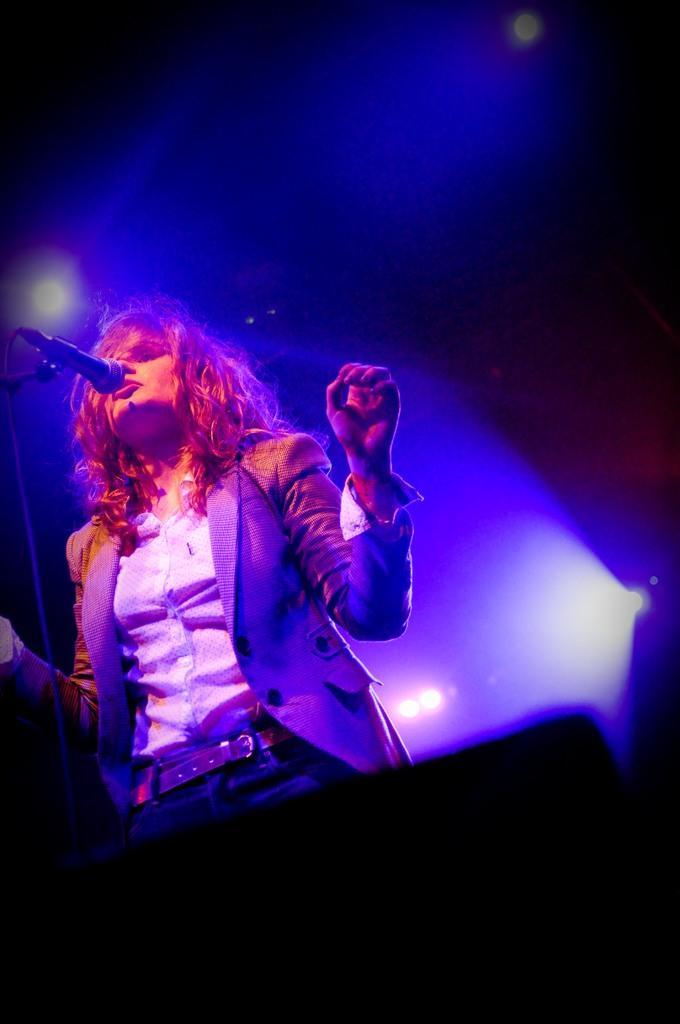Could you give a brief overview of what you see in this image? In this picture we can see a woman is standing and in front of the woman there is a microphone with stand. Behind the women there are lights. 